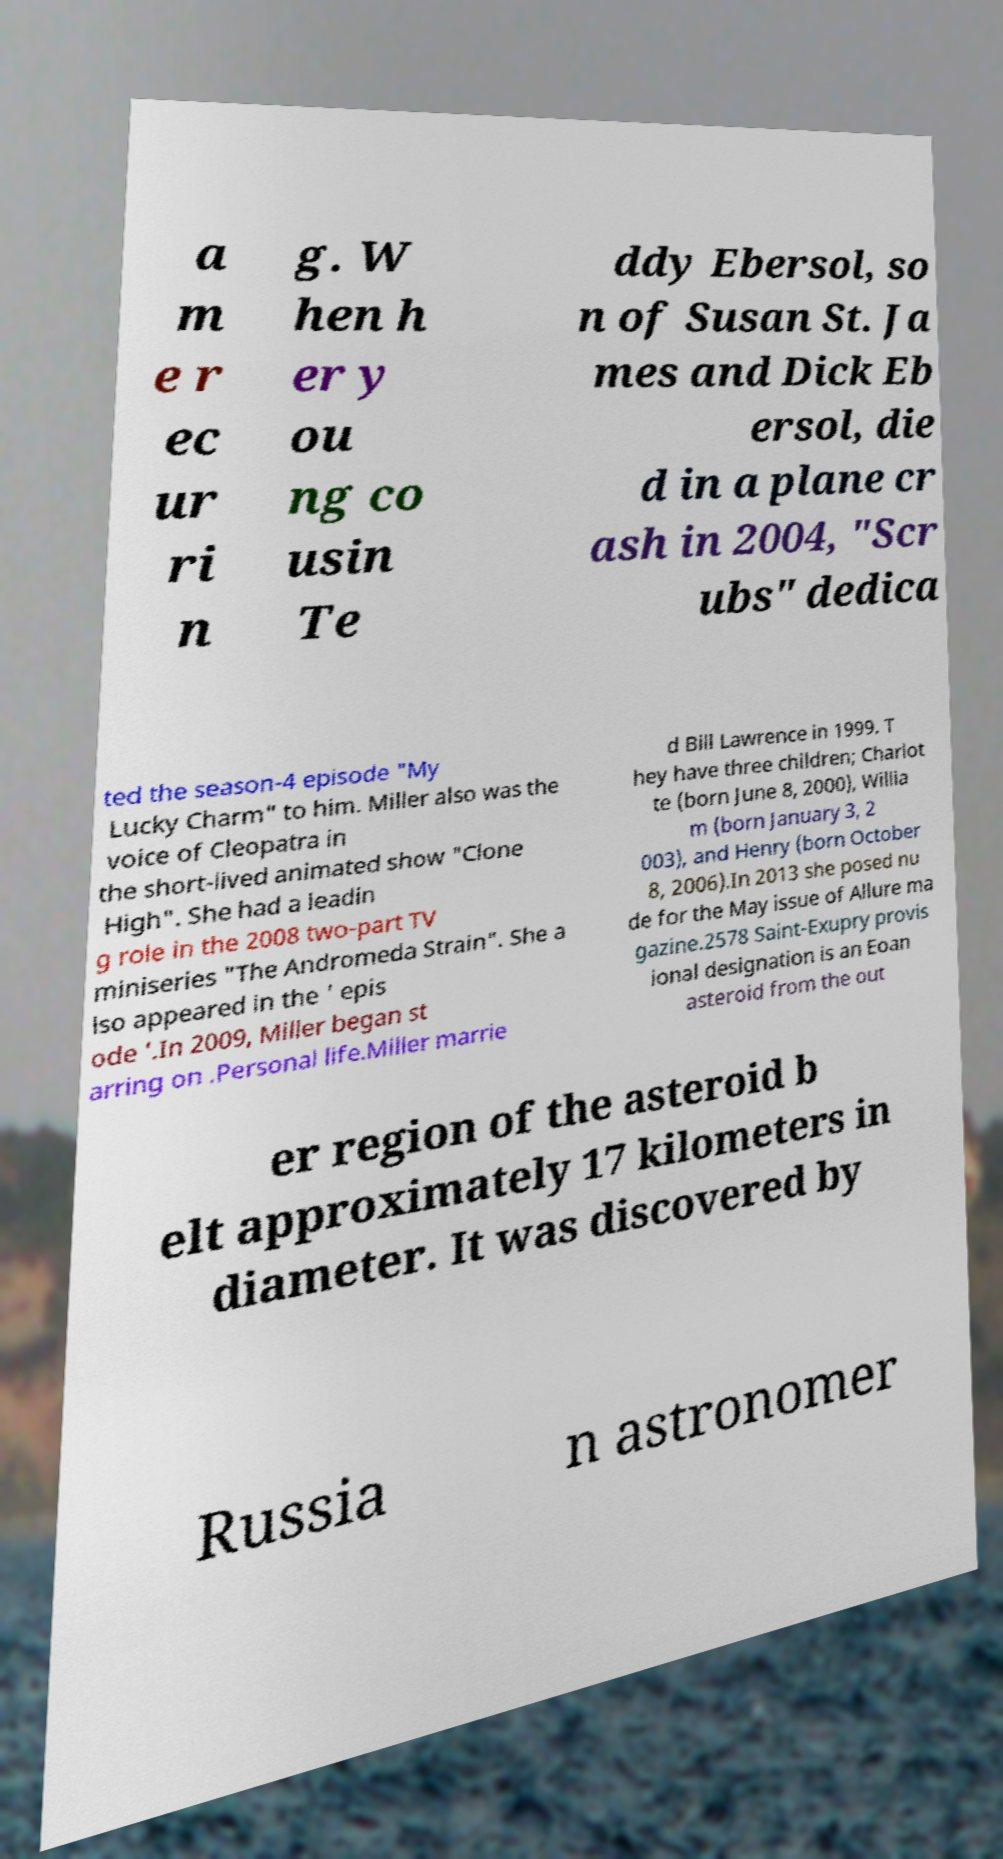Could you assist in decoding the text presented in this image and type it out clearly? a m e r ec ur ri n g. W hen h er y ou ng co usin Te ddy Ebersol, so n of Susan St. Ja mes and Dick Eb ersol, die d in a plane cr ash in 2004, "Scr ubs" dedica ted the season-4 episode "My Lucky Charm" to him. Miller also was the voice of Cleopatra in the short-lived animated show "Clone High". She had a leadin g role in the 2008 two-part TV miniseries "The Andromeda Strain". She a lso appeared in the ' epis ode '.In 2009, Miller began st arring on .Personal life.Miller marrie d Bill Lawrence in 1999. T hey have three children; Charlot te (born June 8, 2000), Willia m (born January 3, 2 003), and Henry (born October 8, 2006).In 2013 she posed nu de for the May issue of Allure ma gazine.2578 Saint-Exupry provis ional designation is an Eoan asteroid from the out er region of the asteroid b elt approximately 17 kilometers in diameter. It was discovered by Russia n astronomer 